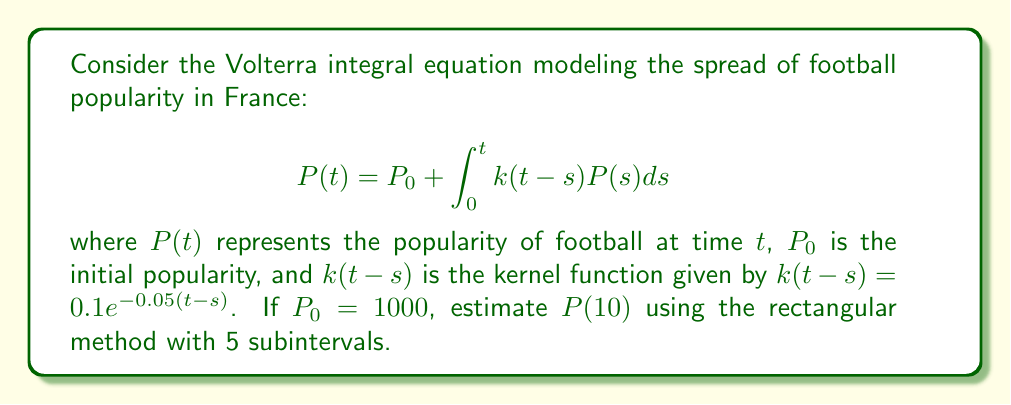Could you help me with this problem? 1) First, we'll divide the interval [0, 10] into 5 subintervals of width $h = 2$.

2) The rectangular method approximates the integral as:
   $$\int_0^t k(t-s)P(s)ds \approx h\sum_{i=1}^5 k(t-s_i)P(s_i)$$
   where $s_i = 2i - 1$ for $i = 1, 2, 3, 4, 5$.

3) We need to solve this equation iteratively. Let's start with $P(s_i) = P_0 = 1000$ for all $i$.

4) For $t = 10$:
   $$P(10) \approx 1000 + 2\sum_{i=1}^5 k(10-s_i)P(s_i)$$

5) Calculate $k(10-s_i)$ for each $i$:
   $k(10-1) = 0.1e^{-0.05(9)} \approx 0.0639$
   $k(10-3) = 0.1e^{-0.05(7)} \approx 0.0707$
   $k(10-5) = 0.1e^{-0.05(5)} \approx 0.0782$
   $k(10-7) = 0.1e^{-0.05(3)} \approx 0.0865$
   $k(10-9) = 0.1e^{-0.05(1)} \approx 0.0951$

6) Sum up:
   $$P(10) \approx 1000 + 2(0.0639 + 0.0707 + 0.0782 + 0.0865 + 0.0951) \cdot 1000$$
   $$P(10) \approx 1000 + 788.8 = 1788.8$$

7) We can improve this estimate by using this value to recalculate $P(s_i)$ for each $i$ and iterate the process. However, for this question, we'll stop at the first iteration.
Answer: $P(10) \approx 1788.8$ 